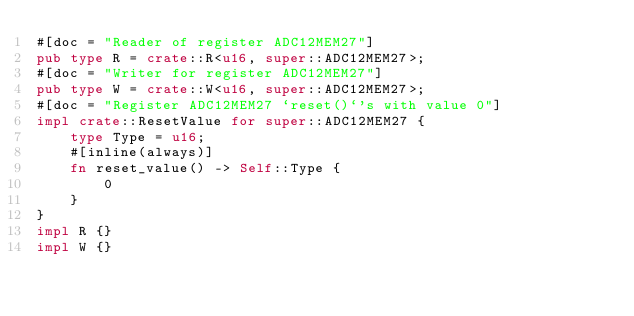<code> <loc_0><loc_0><loc_500><loc_500><_Rust_>#[doc = "Reader of register ADC12MEM27"]
pub type R = crate::R<u16, super::ADC12MEM27>;
#[doc = "Writer for register ADC12MEM27"]
pub type W = crate::W<u16, super::ADC12MEM27>;
#[doc = "Register ADC12MEM27 `reset()`'s with value 0"]
impl crate::ResetValue for super::ADC12MEM27 {
    type Type = u16;
    #[inline(always)]
    fn reset_value() -> Self::Type {
        0
    }
}
impl R {}
impl W {}
</code> 